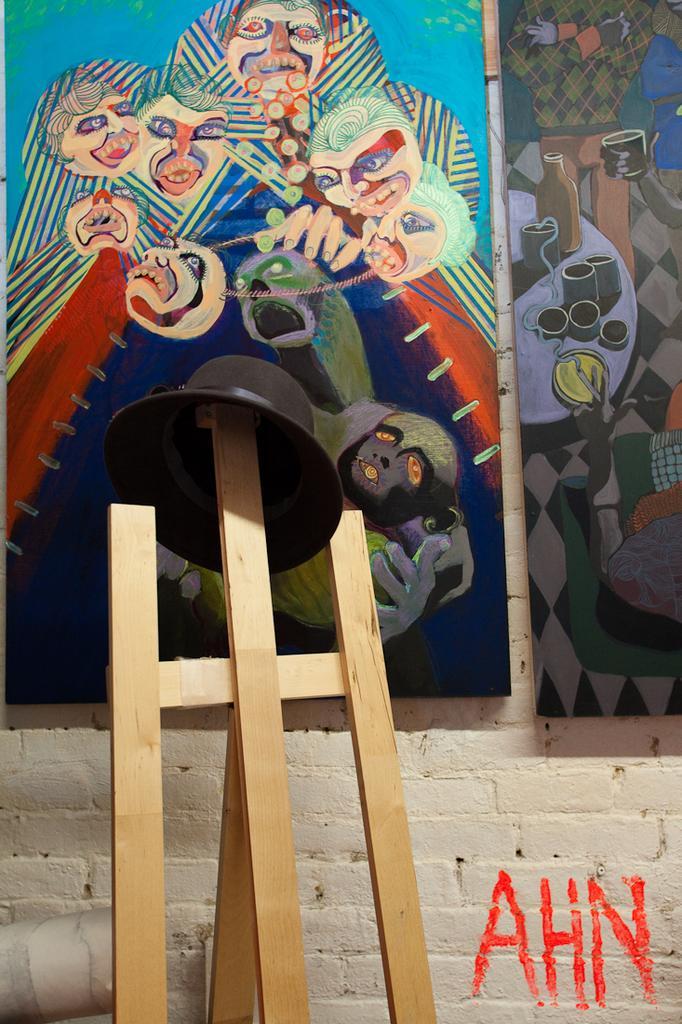Can you describe this image briefly? In the center of the image there is a hat on the wooden sticks. In the background of the image there are posters on the wall. 